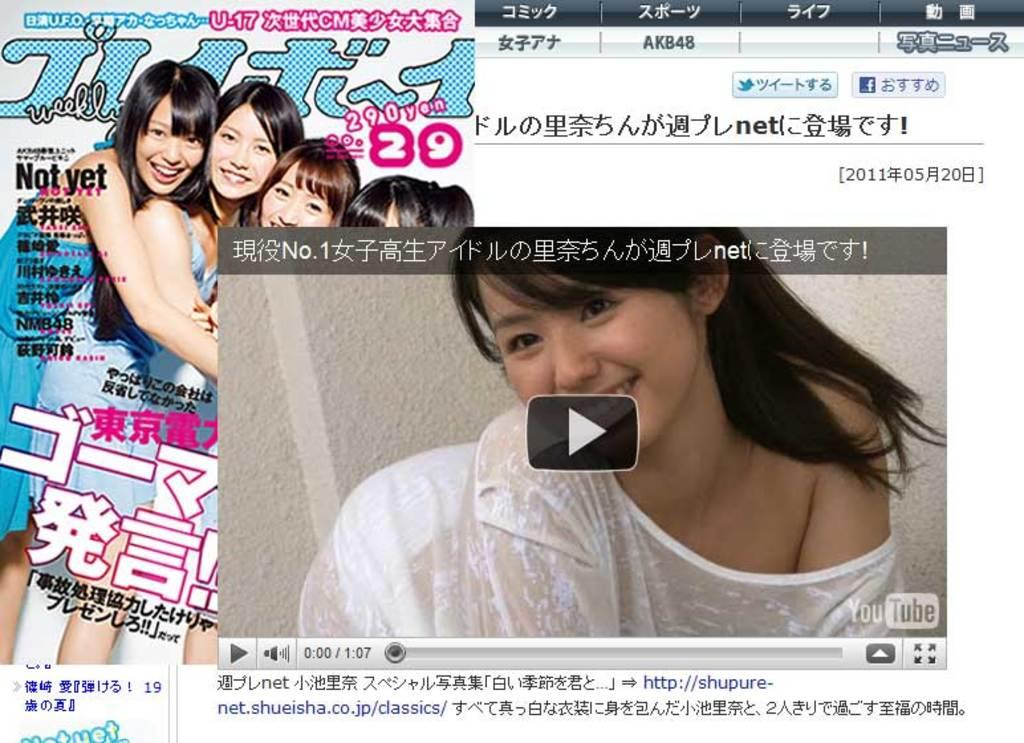What type of content is displayed in the image? The image contains a video and images of four girls. How has the image been modified? The image is edited. What can be found on the right side of the image? There is some transcription on the right side of the image. What type of glove is being worn by the girls in the image? There is no glove visible in the image; it only shows images of four girls and a video. What songs are being sung by the girls in the image? There is no indication of any singing or songs in the image; it only displays images of four girls and a video. 